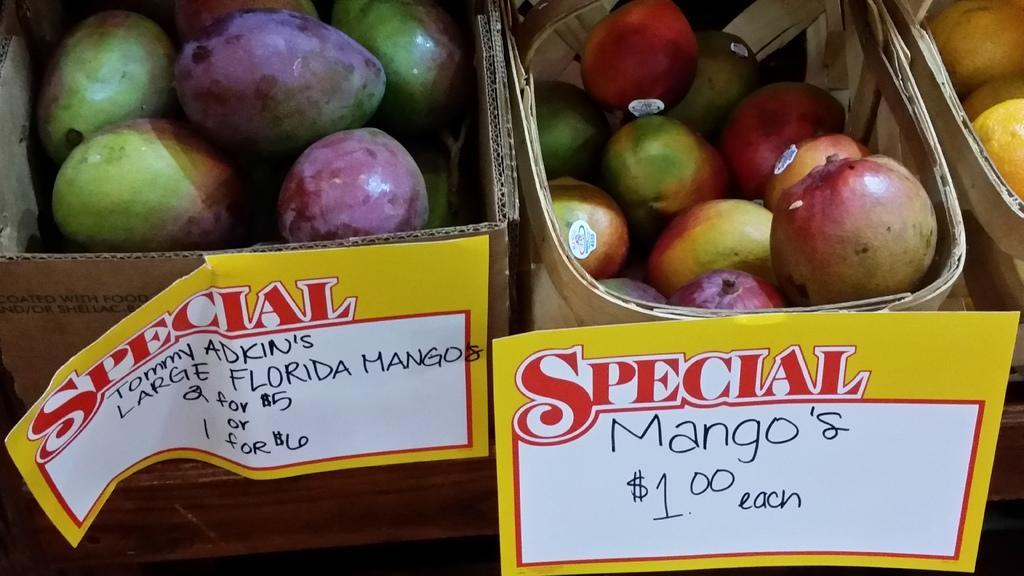Can you describe this image briefly? In this cardboard box and baskets there are fruits. In-front of the cardboard box and basket there are stickers. 